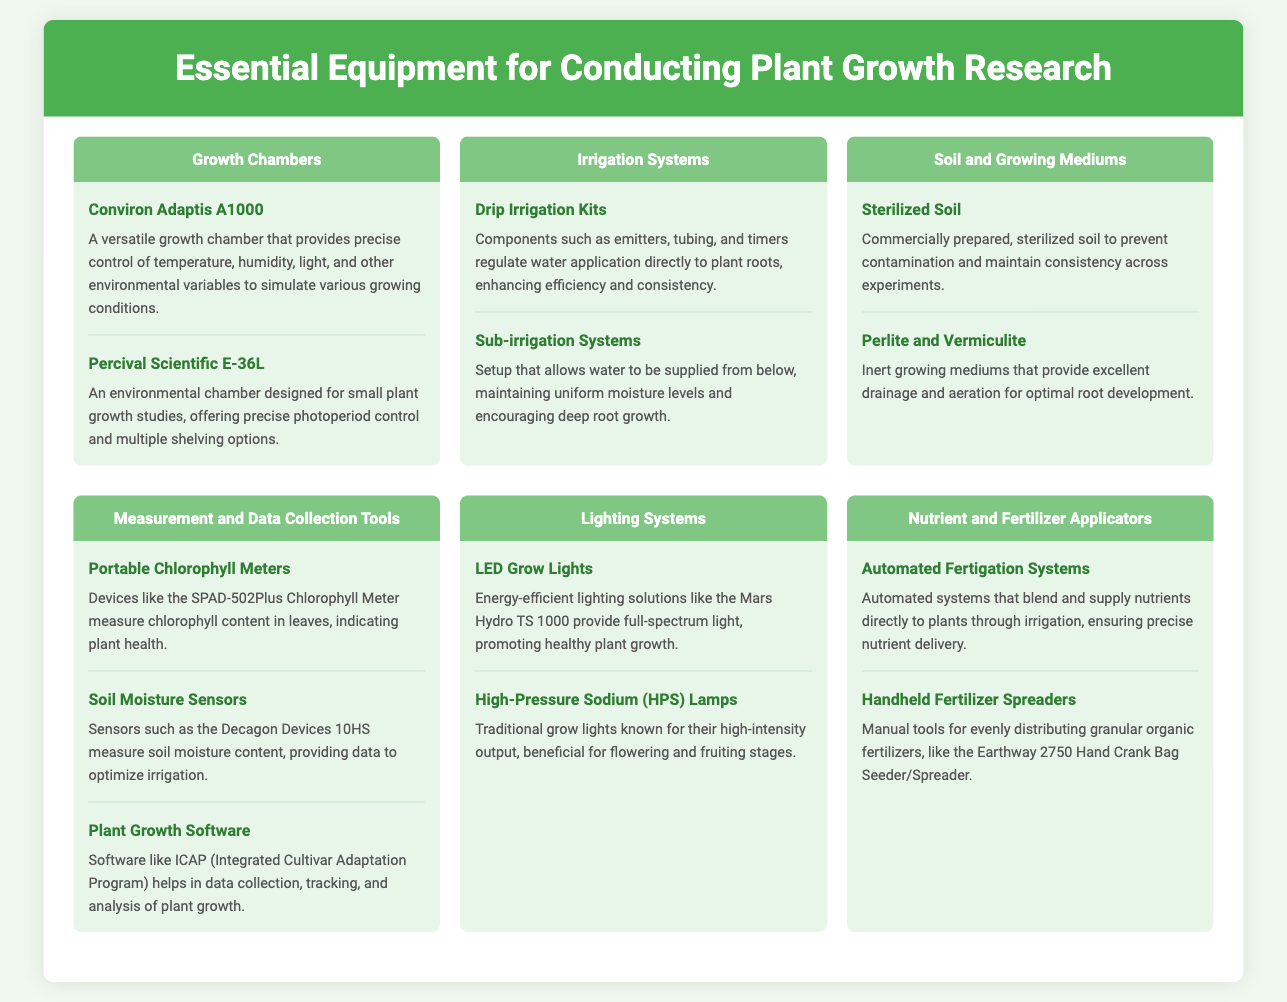what is the title of the document? The title of the document is indicated at the top of the infographic.
Answer: Essential Equipment for Conducting Plant Growth Research how many types of irrigation systems are listed? The document lists two types of irrigation systems under the corresponding section.
Answer: Two name one growth chamber mentioned in the document. The document provides specific examples under the growth chambers section.
Answer: Conviron Adaptis A1000 what is one function of soil moisture sensors? The document describes the purpose of soil moisture sensors in the measurement and data collection tools section.
Answer: measure soil moisture content which lighting system is known for high-intensity output? The document contains information about different lighting systems and their characteristics.
Answer: High-Pressure Sodium (HPS) Lamps how many nutrient and fertilizer applicators are featured? The section about nutrient and fertilizer applicators lists two specific types.
Answer: Two what is the function of automated fertigation systems? The document provides a description of how automated fertigation systems work within their section.
Answer: ensuring precise nutrient delivery name one material used for soil and growing mediums. The document describes types of soil and growing mediums.
Answer: Perlite and Vermiculite 